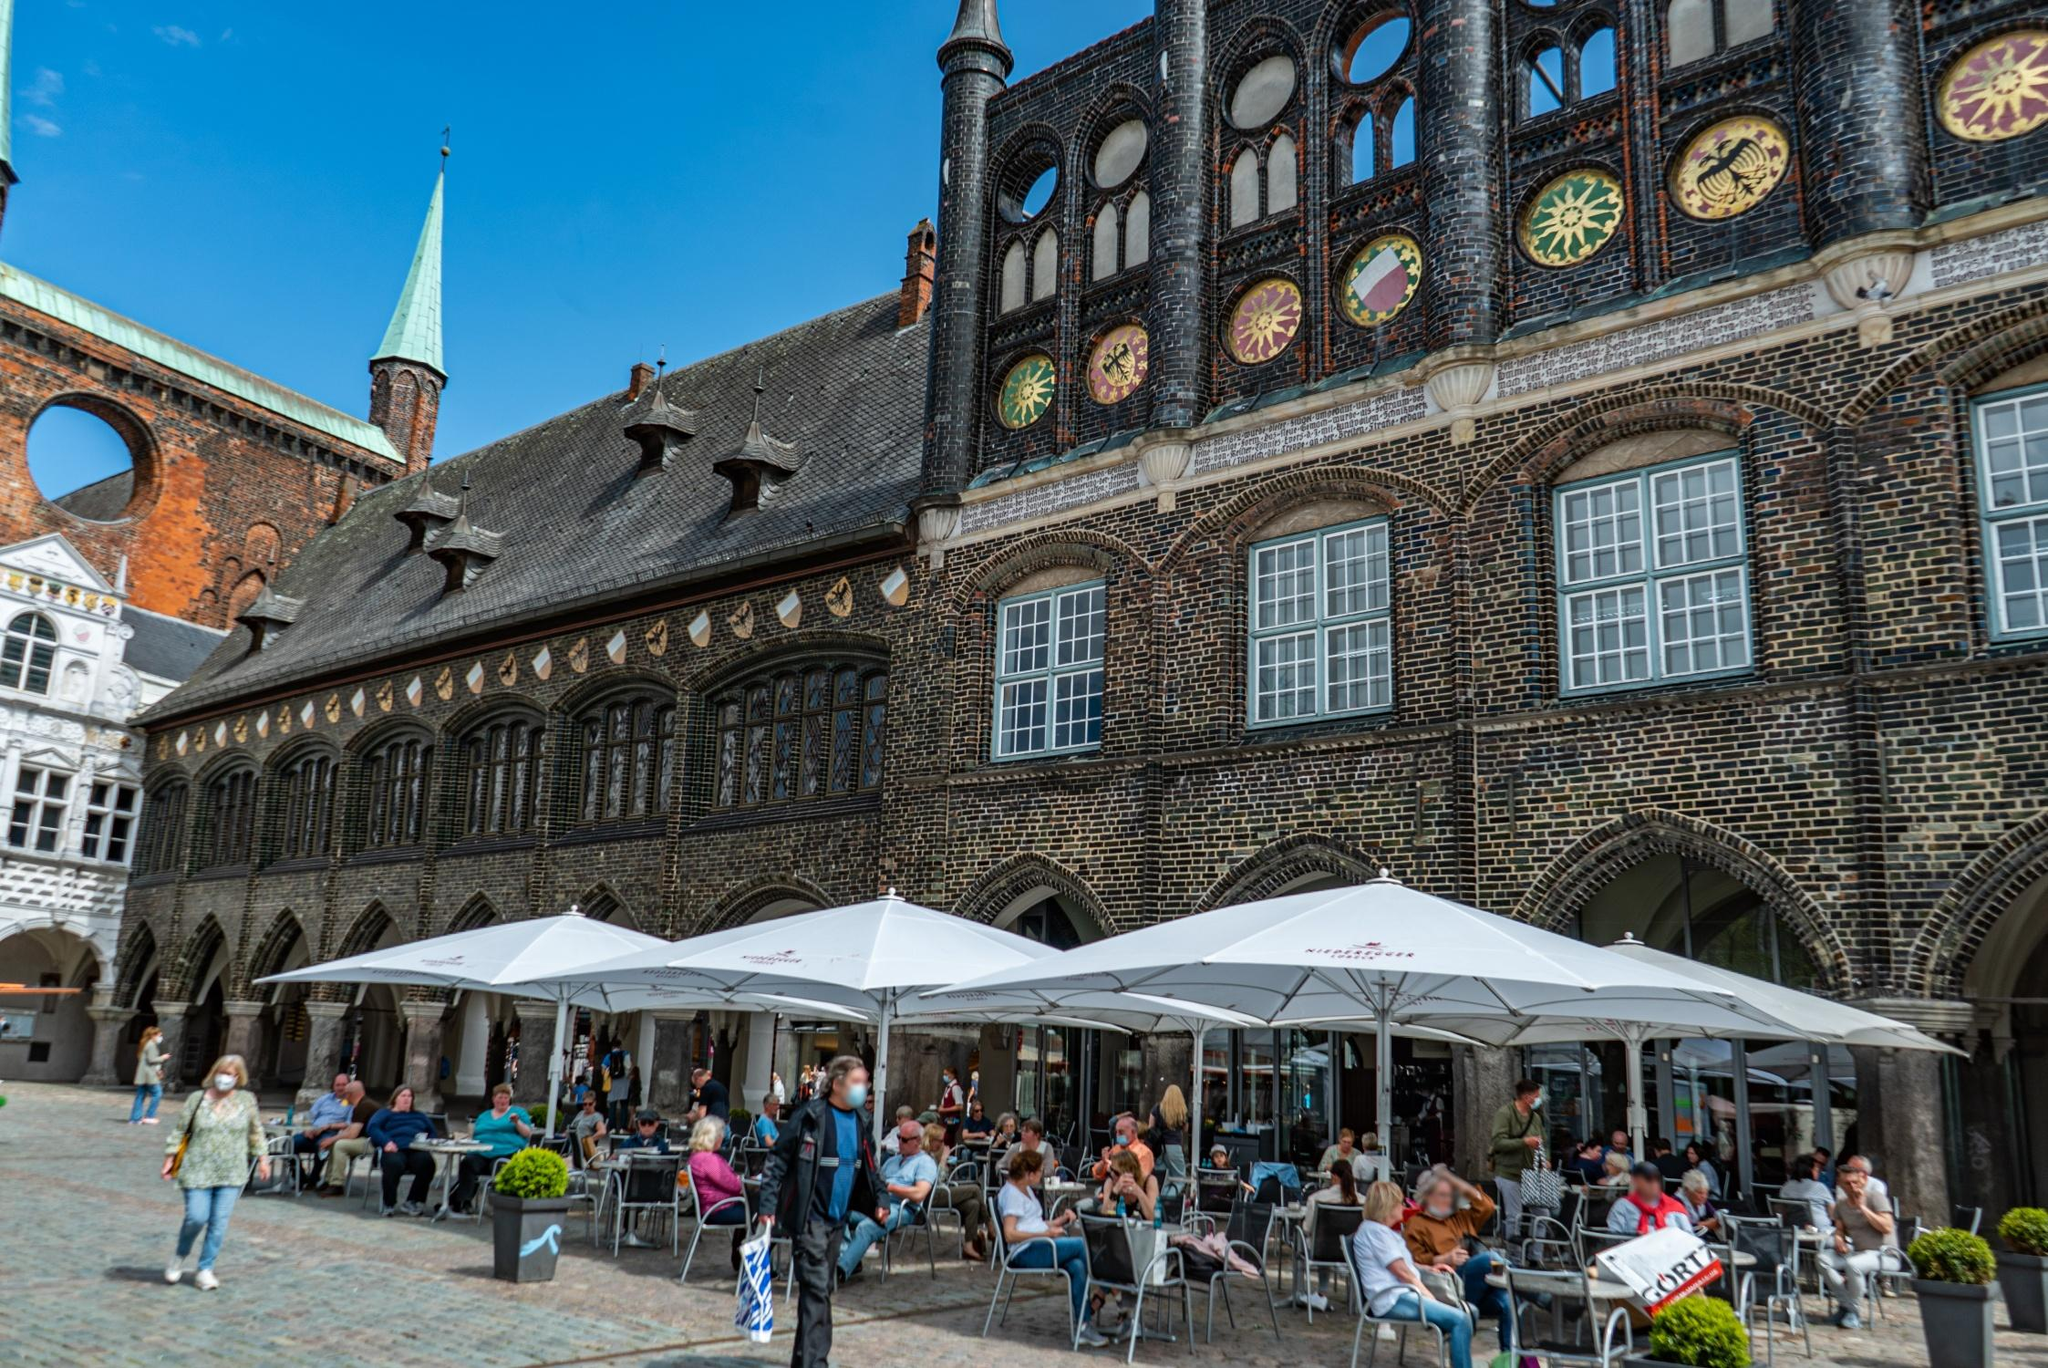Write a detailed description of the given image. The image captures the grandeur of the Lübeck Town Hall in Germany, showcasing its distinctive Gothic architecture. The facade is constructed of dark bricks, creating a robust and historic appearance. Unique circular windows adorned with colorful designs punctuate the upper section, enriching the structure's aesthetic. A green copper spire rises sharply from one side, contrasting against the dark roof. The roof is complex and steep, adding to the building's grandeur. Below, a lively square is bustling with activity. A cozy outdoor café with white umbrellas shelters people enjoying the ambience, socializing, and possibly relishing local delicacies. The image gives a warm, lively feel of the town square with people sitting at tables, some wearing masks, possibly indicating recent photos. The image is taken from a low angle, which emphasizes the height of the town hall and gives the viewer a sense of being in the square, looking up at the magnificent building. The identifier "sa_16091" could potentially be used for further research about this specific landmark. 